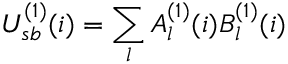Convert formula to latex. <formula><loc_0><loc_0><loc_500><loc_500>U _ { s b } ^ { ( 1 ) } ( i ) = \sum _ { l } A _ { l } ^ { ( 1 ) } ( i ) B _ { l } ^ { ( 1 ) } ( i )</formula> 